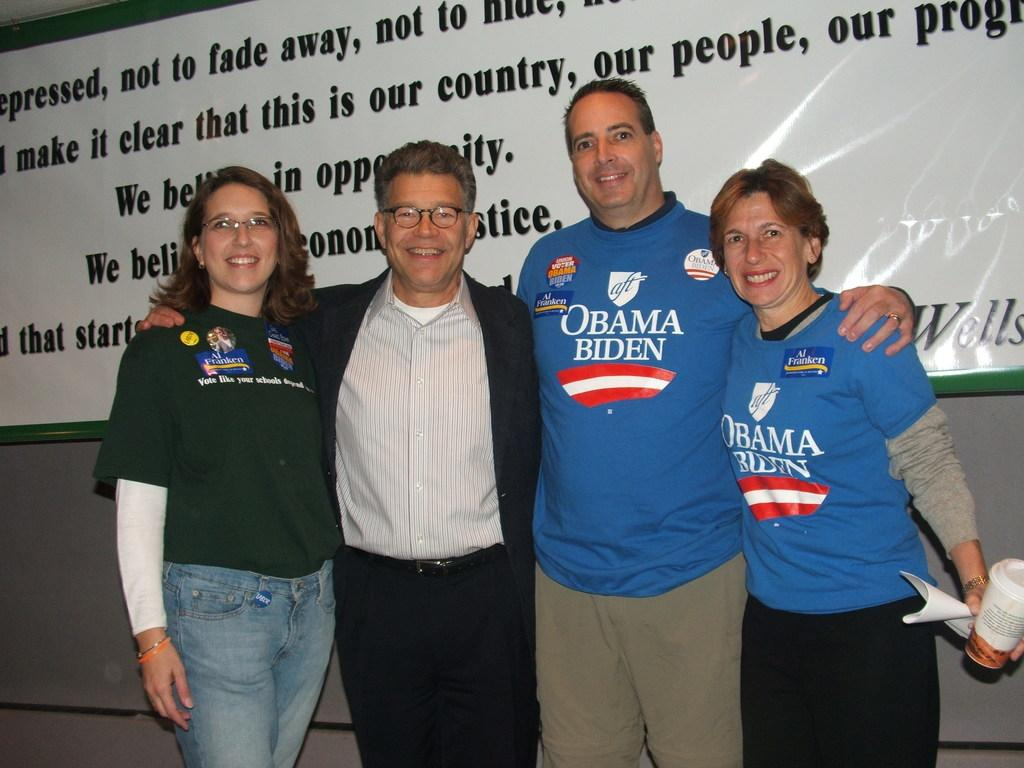<image>
Write a terse but informative summary of the picture. Two of the four people posing are wearing Obama Biden Shirts. 